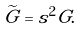Convert formula to latex. <formula><loc_0><loc_0><loc_500><loc_500>\widetilde { G } = s ^ { 2 } G .</formula> 